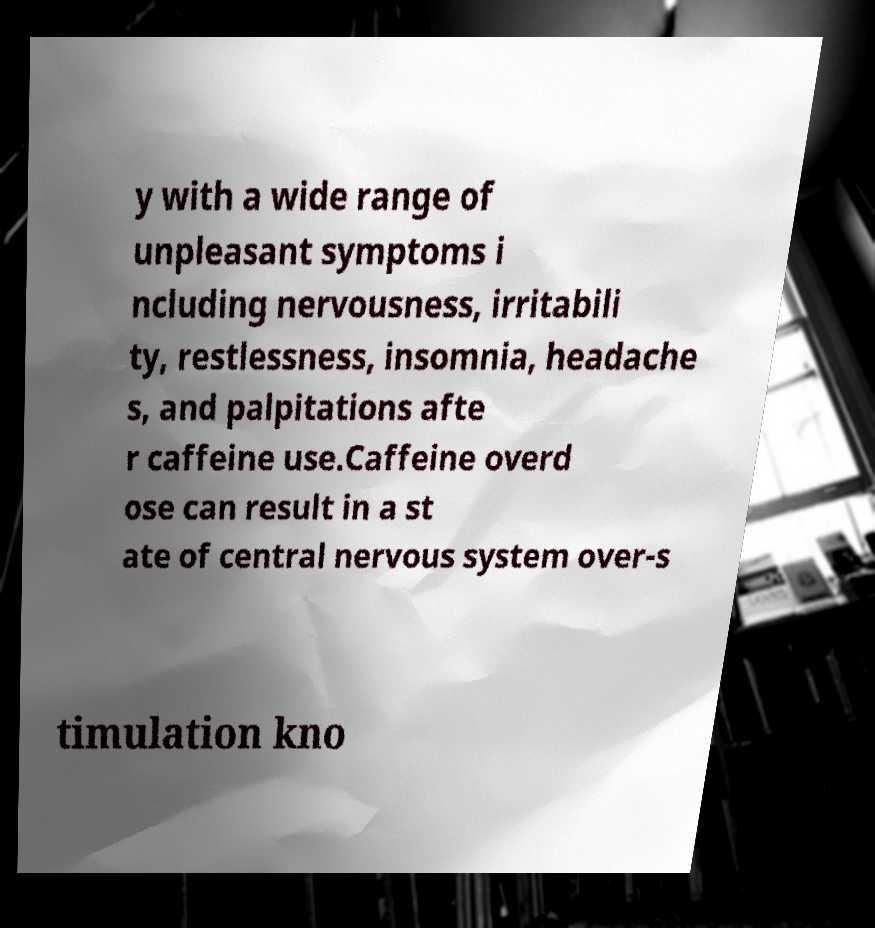There's text embedded in this image that I need extracted. Can you transcribe it verbatim? y with a wide range of unpleasant symptoms i ncluding nervousness, irritabili ty, restlessness, insomnia, headache s, and palpitations afte r caffeine use.Caffeine overd ose can result in a st ate of central nervous system over-s timulation kno 